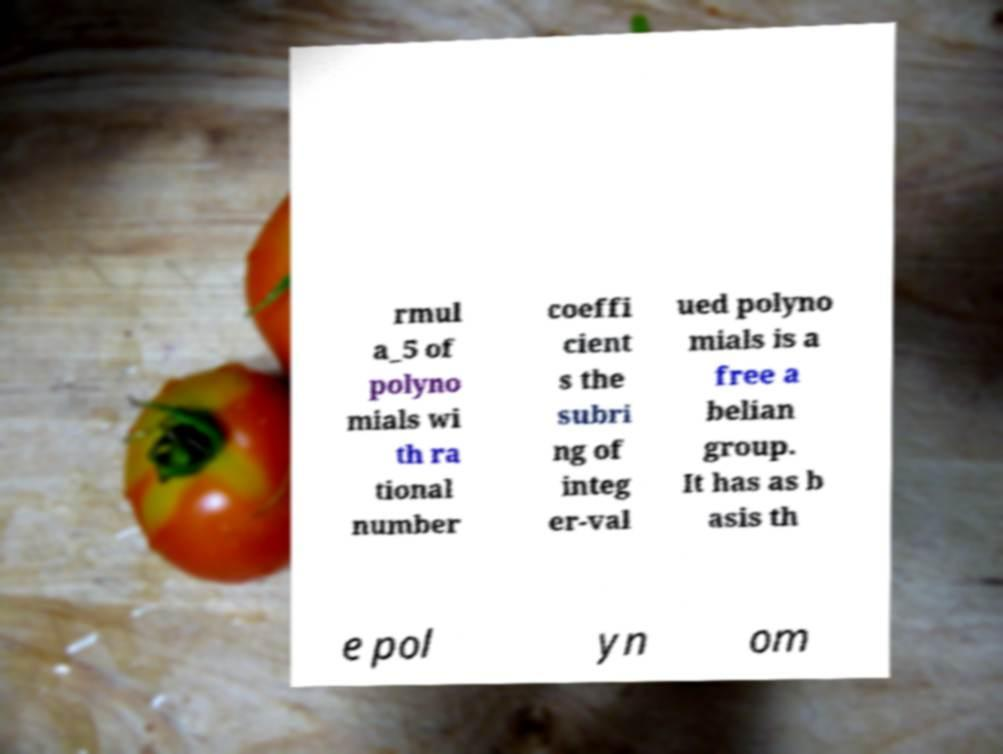What messages or text are displayed in this image? I need them in a readable, typed format. rmul a_5 of polyno mials wi th ra tional number coeffi cient s the subri ng of integ er-val ued polyno mials is a free a belian group. It has as b asis th e pol yn om 